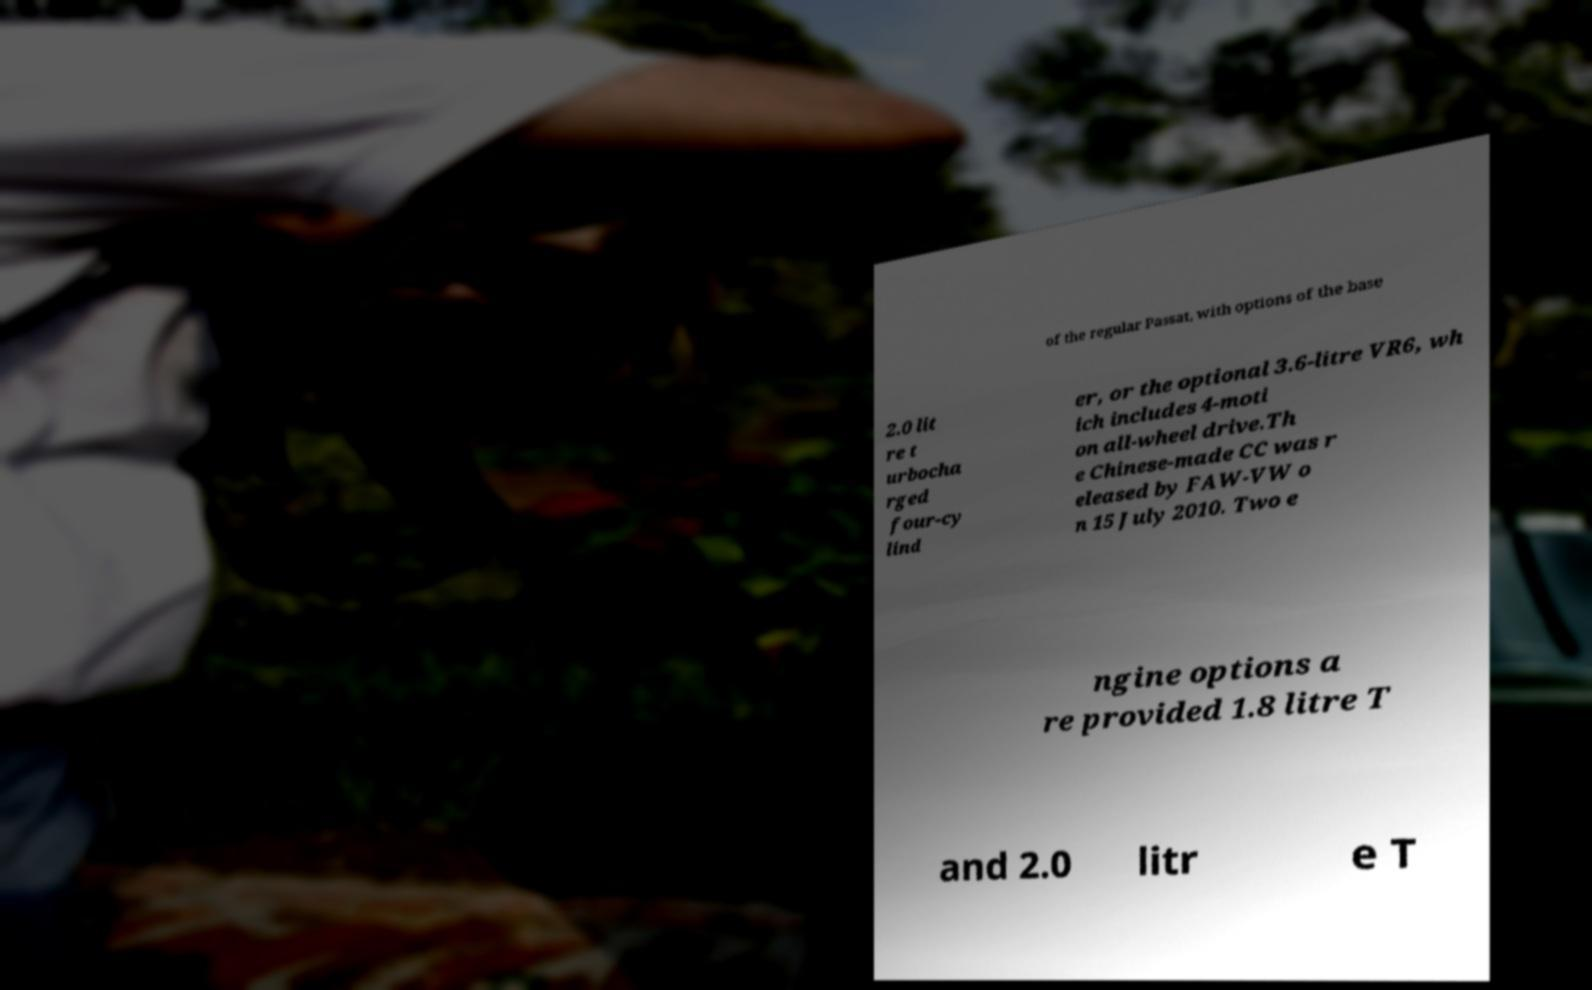There's text embedded in this image that I need extracted. Can you transcribe it verbatim? of the regular Passat, with options of the base 2.0 lit re t urbocha rged four-cy lind er, or the optional 3.6-litre VR6, wh ich includes 4-moti on all-wheel drive.Th e Chinese-made CC was r eleased by FAW-VW o n 15 July 2010. Two e ngine options a re provided 1.8 litre T and 2.0 litr e T 